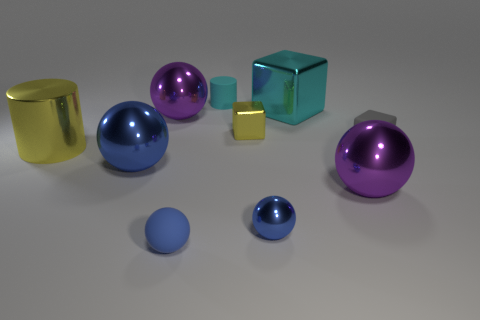What number of objects are cyan matte things or cyan spheres?
Keep it short and to the point. 1. What is the size of the yellow shiny object that is the same shape as the tiny cyan thing?
Your response must be concise. Large. Are there more tiny metallic blocks that are in front of the big cyan object than cyan matte cylinders?
Provide a short and direct response. No. Does the tiny gray object have the same material as the small yellow cube?
Keep it short and to the point. No. What number of objects are either large purple objects that are in front of the rubber block or objects in front of the cyan cylinder?
Your answer should be very brief. 9. What color is the other tiny thing that is the same shape as the gray matte object?
Keep it short and to the point. Yellow. How many matte things are the same color as the metal cylinder?
Make the answer very short. 0. Is the color of the rubber ball the same as the large shiny cube?
Provide a short and direct response. No. What number of things are purple metallic balls in front of the large yellow shiny cylinder or blue balls?
Keep it short and to the point. 4. The object that is right of the purple shiny ball in front of the yellow metal object that is to the right of the big yellow metal cylinder is what color?
Keep it short and to the point. Gray. 